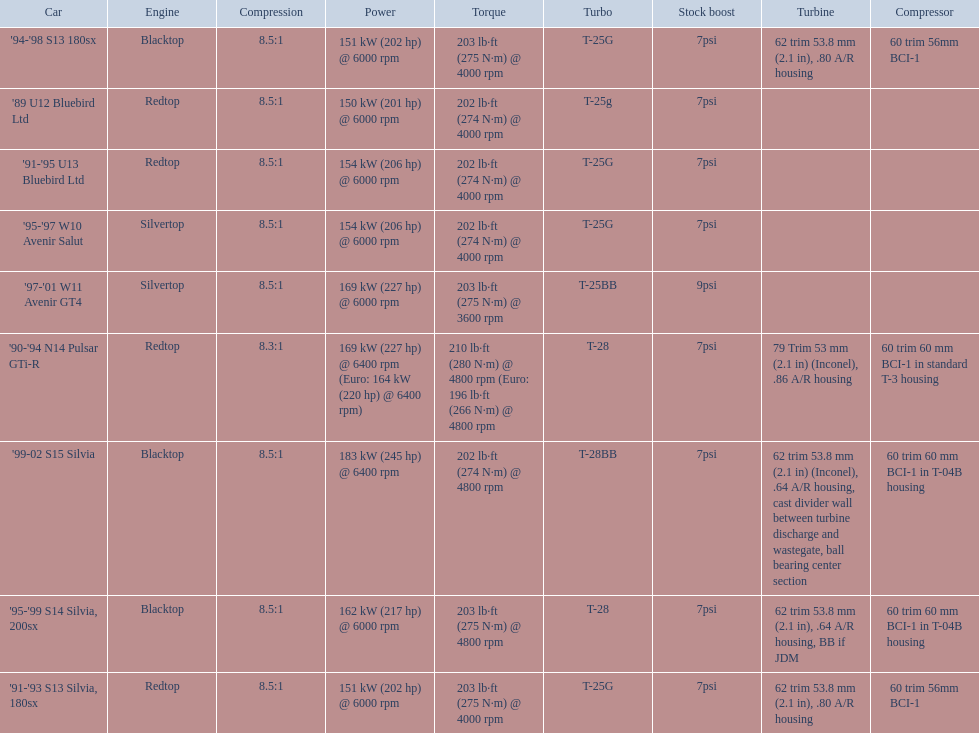What are all of the cars? '89 U12 Bluebird Ltd, '91-'95 U13 Bluebird Ltd, '95-'97 W10 Avenir Salut, '97-'01 W11 Avenir GT4, '90-'94 N14 Pulsar GTi-R, '91-'93 S13 Silvia, 180sx, '94-'98 S13 180sx, '95-'99 S14 Silvia, 200sx, '99-02 S15 Silvia. What is their rated power? 150 kW (201 hp) @ 6000 rpm, 154 kW (206 hp) @ 6000 rpm, 154 kW (206 hp) @ 6000 rpm, 169 kW (227 hp) @ 6000 rpm, 169 kW (227 hp) @ 6400 rpm (Euro: 164 kW (220 hp) @ 6400 rpm), 151 kW (202 hp) @ 6000 rpm, 151 kW (202 hp) @ 6000 rpm, 162 kW (217 hp) @ 6000 rpm, 183 kW (245 hp) @ 6400 rpm. Which car has the most power? '99-02 S15 Silvia. 